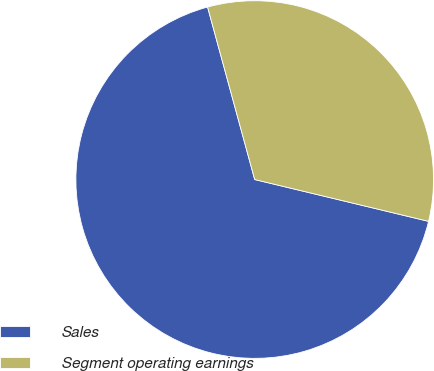<chart> <loc_0><loc_0><loc_500><loc_500><pie_chart><fcel>Sales<fcel>Segment operating earnings<nl><fcel>67.0%<fcel>33.0%<nl></chart> 